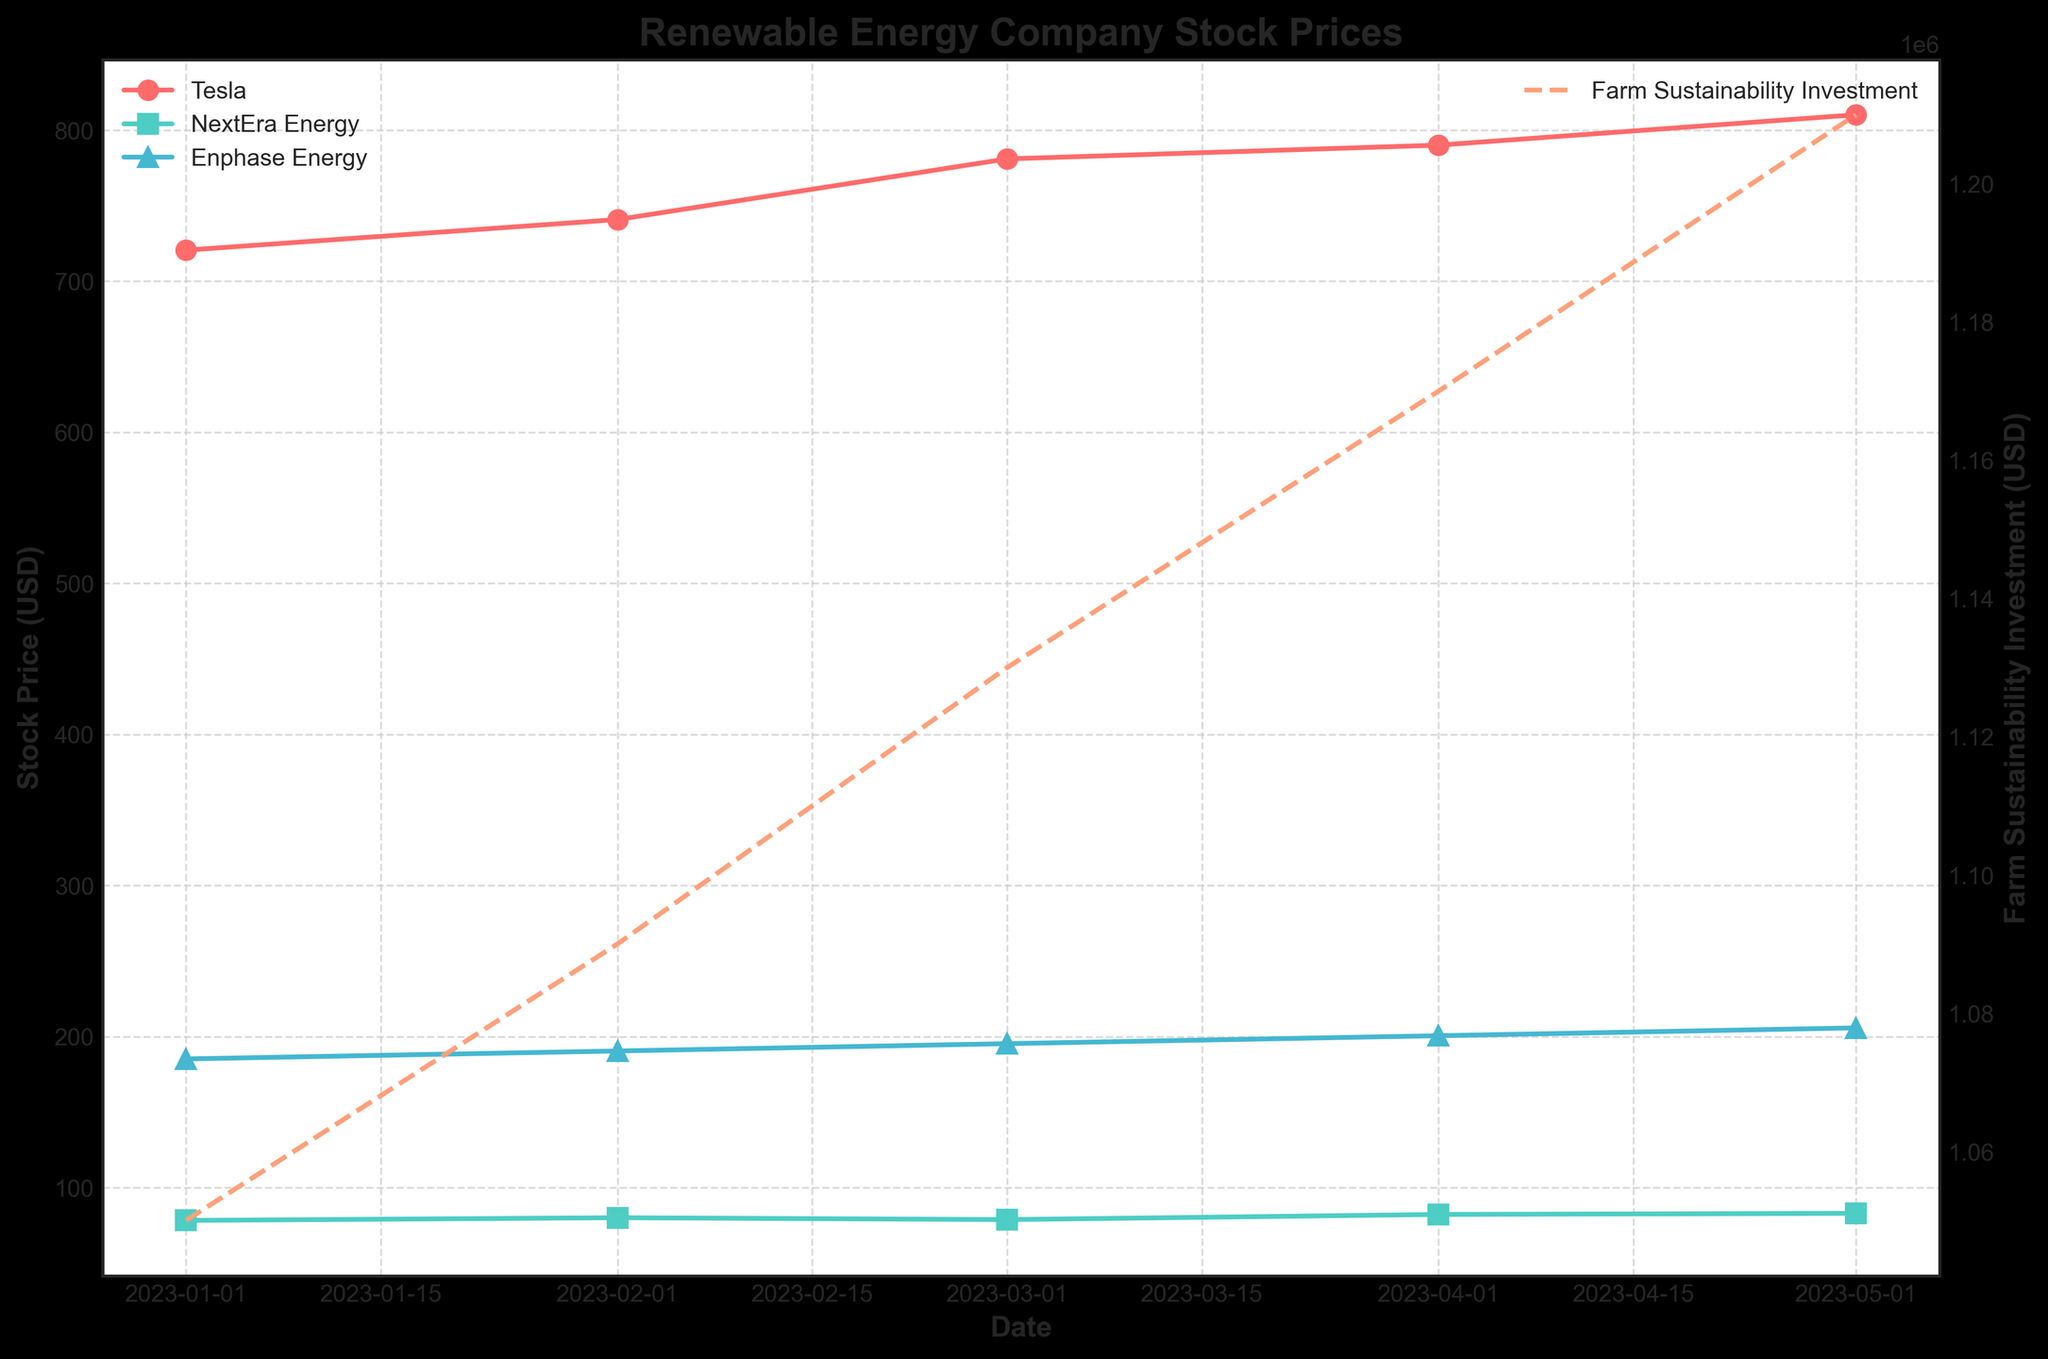What's the title of the figure? The title is usually placed at the top of the figure in a larger font and it summarizes the theme of the plot. Here, the title is 'Renewable Energy Company Stock Prices'.
Answer: Renewable Energy Company Stock Prices Which company has the highest stock price in January 2023? In January 2023, we observe the stock prices for Tesla, NextEra Energy, and Enphase Energy. Among these, Tesla has the highest stock price at 720.50 USD.
Answer: Tesla What were the farm sustainability investments in February 2023 compared to April 2023? In February 2023, farm sustainability investments were 520,000 USD, while in April 2023, they increased to 560,000 USD. To compare, we see an increase.
Answer: Increased What trend do you observe in Tesla's stock price from January 2023 to May 2023? Charting Tesla's stock prices from January to May, we see the values 720.50, 740.75, 780.90, 790.00, and 810.10 USD, showing a consistent upward trend.
Answer: Upward trend Which company's stock price experienced a decline in March 2023? In March 2023, among Tesla, NextEra Energy, and Enphase Energy, only NextEra Energy showed a decline in stock price from February to March: it went from 80.10 to 78.85 USD.
Answer: NextEra Energy How does the farm sustainability investment trend compare to the overall trend in stock prices? While individual stock prices vary, the farm sustainability investment shows a consistent upward trend from 500,000 USD in January to 580,000 USD in May. This trend is parallel to the overall increase in stock prices, especially noted in Tesla and Enphase Energy.
Answer: Upward trend What is the difference in stock prices between Tesla and Enphase Energy in May 2023? In May, Tesla's stock price is 810.10 USD and Enphase Energy's is 205.75 USD. The difference is 810.10 - 205.75 = 604.35 USD.
Answer: 604.35 USD Which company consistently had the lowest stock price from January to May 2023? Observing the data for Tesla, NextEra Energy, and Enphase Energy from January to May, NextEra Energy consistently had the lowest stock prices.
Answer: NextEra Energy 